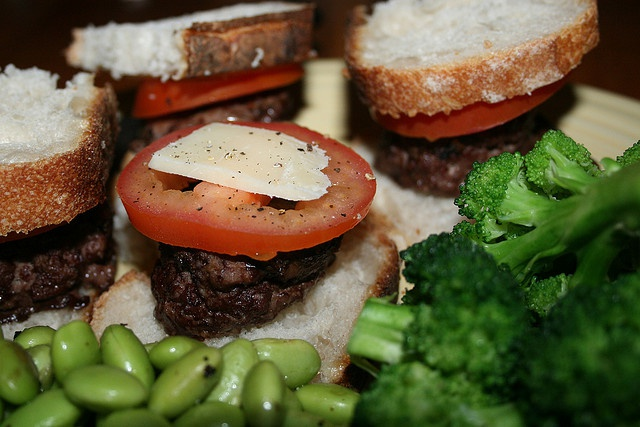Describe the objects in this image and their specific colors. I can see broccoli in black, darkgreen, and green tones, sandwich in black, darkgray, brown, and tan tones, sandwich in black, darkgray, maroon, and brown tones, sandwich in black, maroon, darkgray, and brown tones, and sandwich in black, maroon, and darkgray tones in this image. 